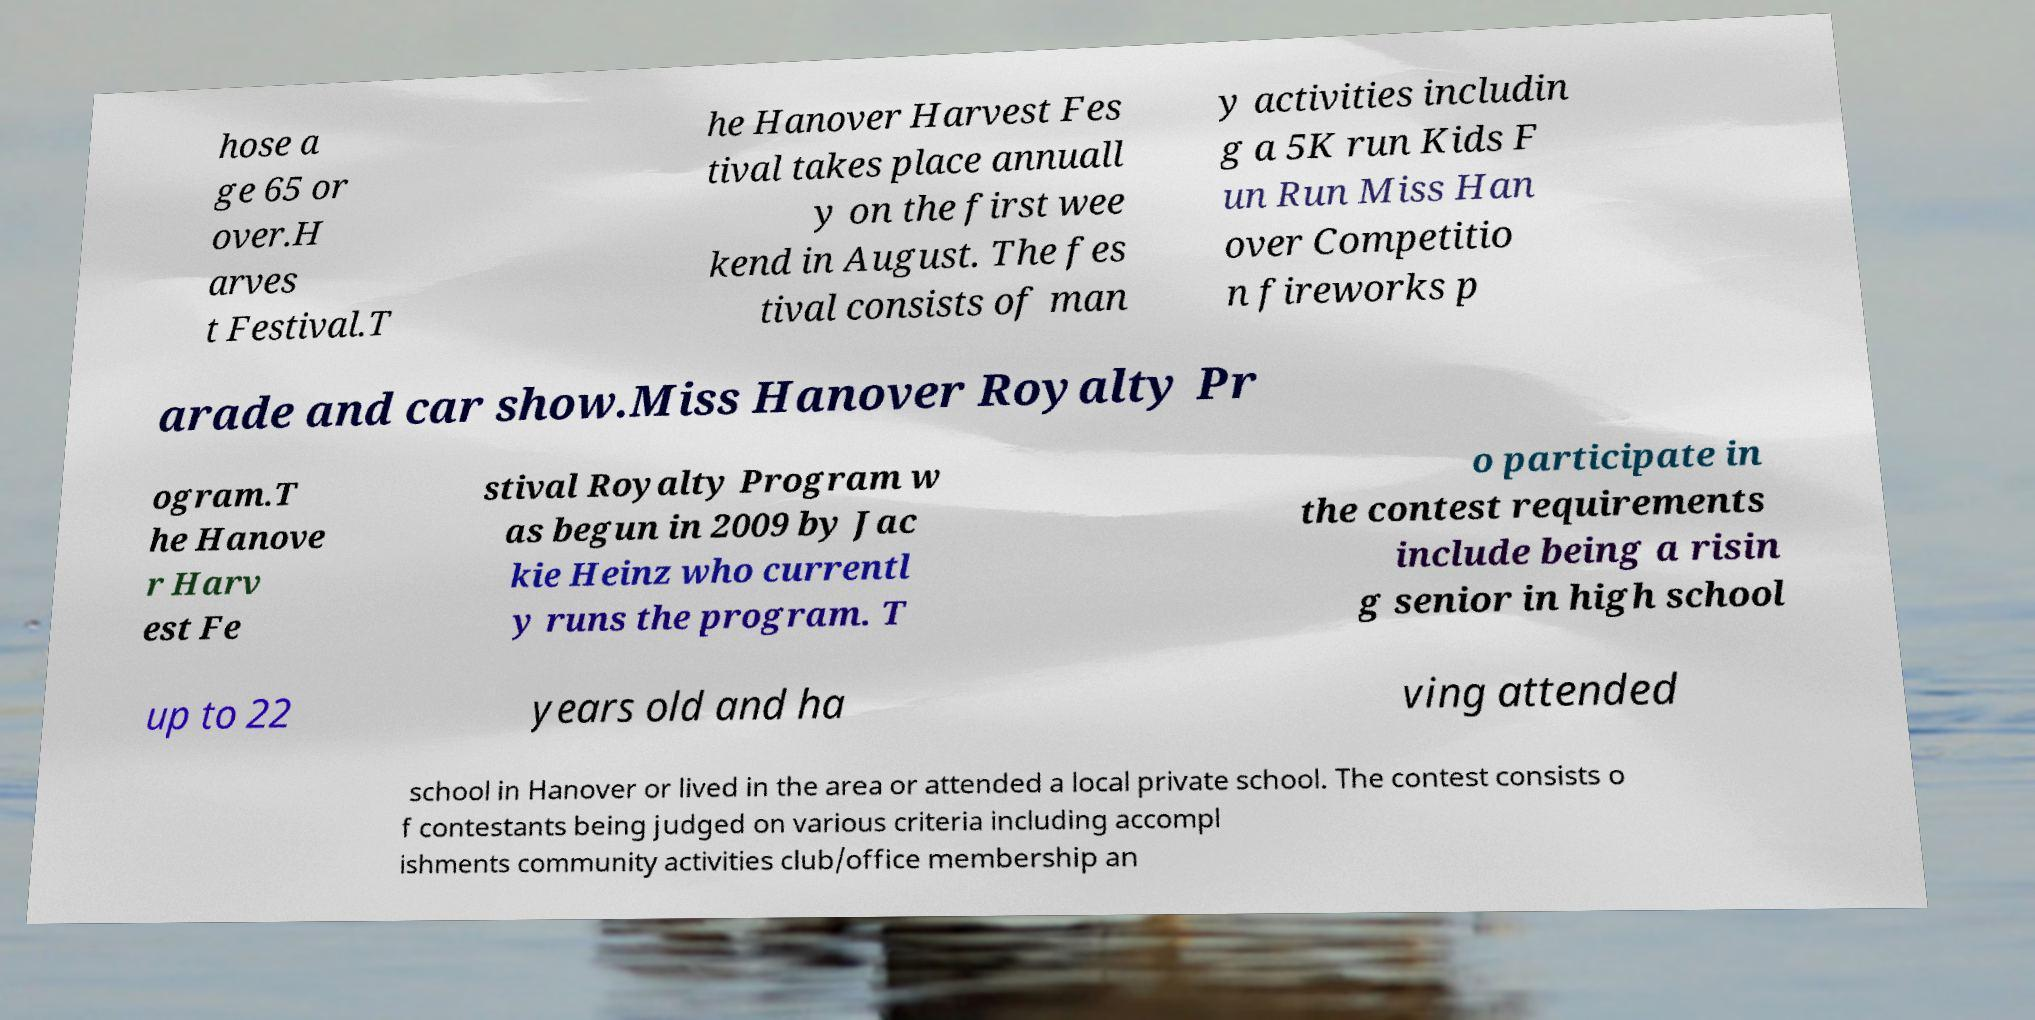There's text embedded in this image that I need extracted. Can you transcribe it verbatim? hose a ge 65 or over.H arves t Festival.T he Hanover Harvest Fes tival takes place annuall y on the first wee kend in August. The fes tival consists of man y activities includin g a 5K run Kids F un Run Miss Han over Competitio n fireworks p arade and car show.Miss Hanover Royalty Pr ogram.T he Hanove r Harv est Fe stival Royalty Program w as begun in 2009 by Jac kie Heinz who currentl y runs the program. T o participate in the contest requirements include being a risin g senior in high school up to 22 years old and ha ving attended school in Hanover or lived in the area or attended a local private school. The contest consists o f contestants being judged on various criteria including accompl ishments community activities club/office membership an 